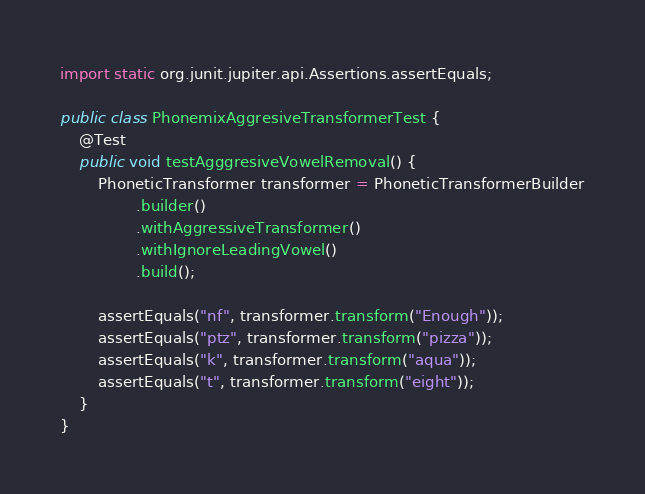<code> <loc_0><loc_0><loc_500><loc_500><_Java_>
import static org.junit.jupiter.api.Assertions.assertEquals;

public class PhonemixAggresiveTransformerTest {
    @Test
    public void testAgggresiveVowelRemoval() {
        PhoneticTransformer transformer = PhoneticTransformerBuilder
                .builder()
                .withAggressiveTransformer()
                .withIgnoreLeadingVowel()
                .build();

        assertEquals("nf", transformer.transform("Enough"));
        assertEquals("ptz", transformer.transform("pizza"));
        assertEquals("k", transformer.transform("aqua"));
        assertEquals("t", transformer.transform("eight"));
    }
}
</code> 